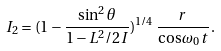Convert formula to latex. <formula><loc_0><loc_0><loc_500><loc_500>I _ { 2 } = ( 1 - \frac { \sin ^ { 2 } \theta } { 1 - L ^ { 2 } / 2 I } ) ^ { 1 / 4 } \, \frac { r } { \cos \omega _ { 0 } t } \, .</formula> 